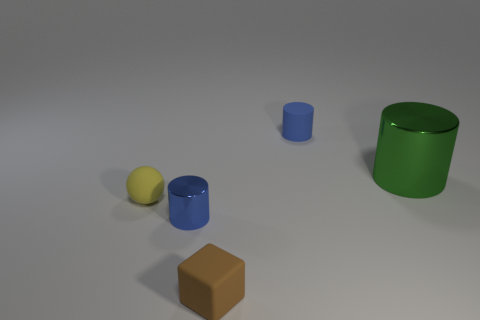Subtract all small blue cylinders. How many cylinders are left? 1 Add 2 tiny gray balls. How many objects exist? 7 Subtract all cylinders. How many objects are left? 2 Subtract all big cyan cubes. Subtract all large cylinders. How many objects are left? 4 Add 3 big green cylinders. How many big green cylinders are left? 4 Add 3 tiny red cubes. How many tiny red cubes exist? 3 Subtract 0 purple cylinders. How many objects are left? 5 